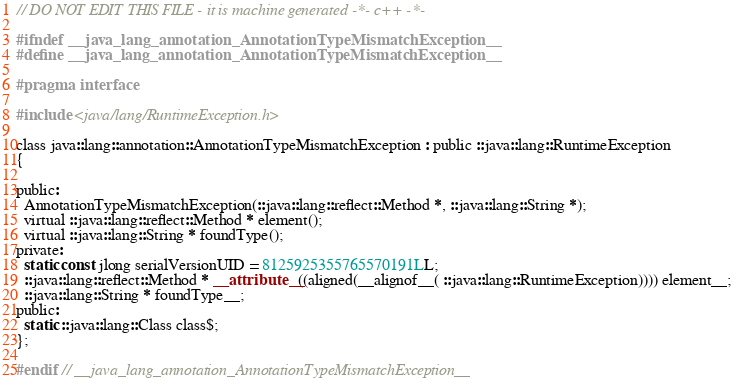Convert code to text. <code><loc_0><loc_0><loc_500><loc_500><_C_>
// DO NOT EDIT THIS FILE - it is machine generated -*- c++ -*-

#ifndef __java_lang_annotation_AnnotationTypeMismatchException__
#define __java_lang_annotation_AnnotationTypeMismatchException__

#pragma interface

#include <java/lang/RuntimeException.h>

class java::lang::annotation::AnnotationTypeMismatchException : public ::java::lang::RuntimeException
{

public:
  AnnotationTypeMismatchException(::java::lang::reflect::Method *, ::java::lang::String *);
  virtual ::java::lang::reflect::Method * element();
  virtual ::java::lang::String * foundType();
private:
  static const jlong serialVersionUID = 8125925355765570191LL;
  ::java::lang::reflect::Method * __attribute__((aligned(__alignof__( ::java::lang::RuntimeException)))) element__;
  ::java::lang::String * foundType__;
public:
  static ::java::lang::Class class$;
};

#endif // __java_lang_annotation_AnnotationTypeMismatchException__
</code> 